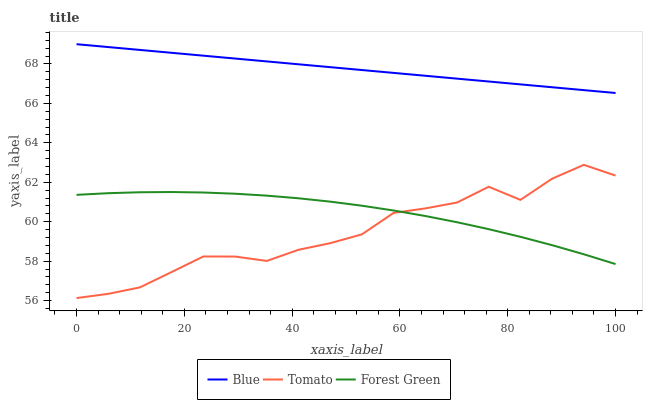Does Tomato have the minimum area under the curve?
Answer yes or no. Yes. Does Blue have the maximum area under the curve?
Answer yes or no. Yes. Does Forest Green have the minimum area under the curve?
Answer yes or no. No. Does Forest Green have the maximum area under the curve?
Answer yes or no. No. Is Blue the smoothest?
Answer yes or no. Yes. Is Tomato the roughest?
Answer yes or no. Yes. Is Forest Green the smoothest?
Answer yes or no. No. Is Forest Green the roughest?
Answer yes or no. No. Does Tomato have the lowest value?
Answer yes or no. Yes. Does Forest Green have the lowest value?
Answer yes or no. No. Does Blue have the highest value?
Answer yes or no. Yes. Does Tomato have the highest value?
Answer yes or no. No. Is Tomato less than Blue?
Answer yes or no. Yes. Is Blue greater than Tomato?
Answer yes or no. Yes. Does Forest Green intersect Tomato?
Answer yes or no. Yes. Is Forest Green less than Tomato?
Answer yes or no. No. Is Forest Green greater than Tomato?
Answer yes or no. No. Does Tomato intersect Blue?
Answer yes or no. No. 